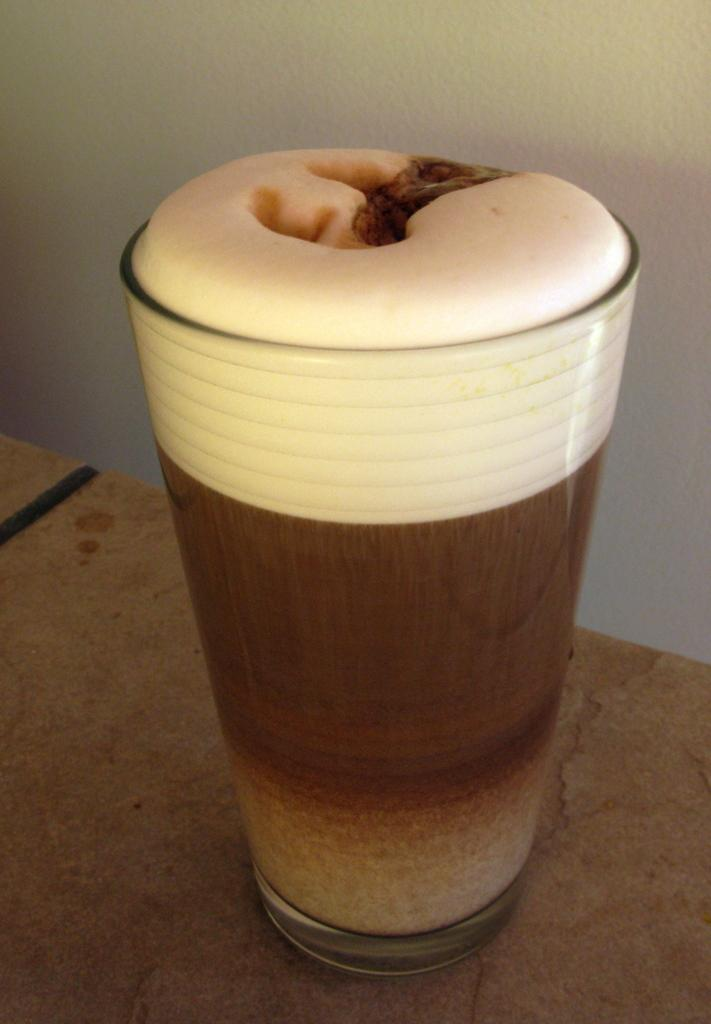What is in the glass that is visible in the image? There is a glass with liquid in the image. Where is the glass located in the image? The glass is on a platform in the image. What can be seen in the background of the image? There is a wall in the background of the image. What type of elbow is visible in the image? There is no elbow present in the image. What is being served for dinner in the image? The image does not depict a dinner scene, so it cannot be determined what is being served. 